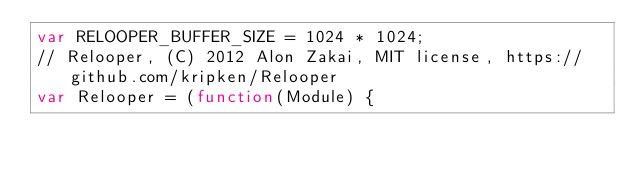Convert code to text. <code><loc_0><loc_0><loc_500><loc_500><_JavaScript_>var RELOOPER_BUFFER_SIZE = 1024 * 1024;
// Relooper, (C) 2012 Alon Zakai, MIT license, https://github.com/kripken/Relooper
var Relooper = (function(Module) {</code> 